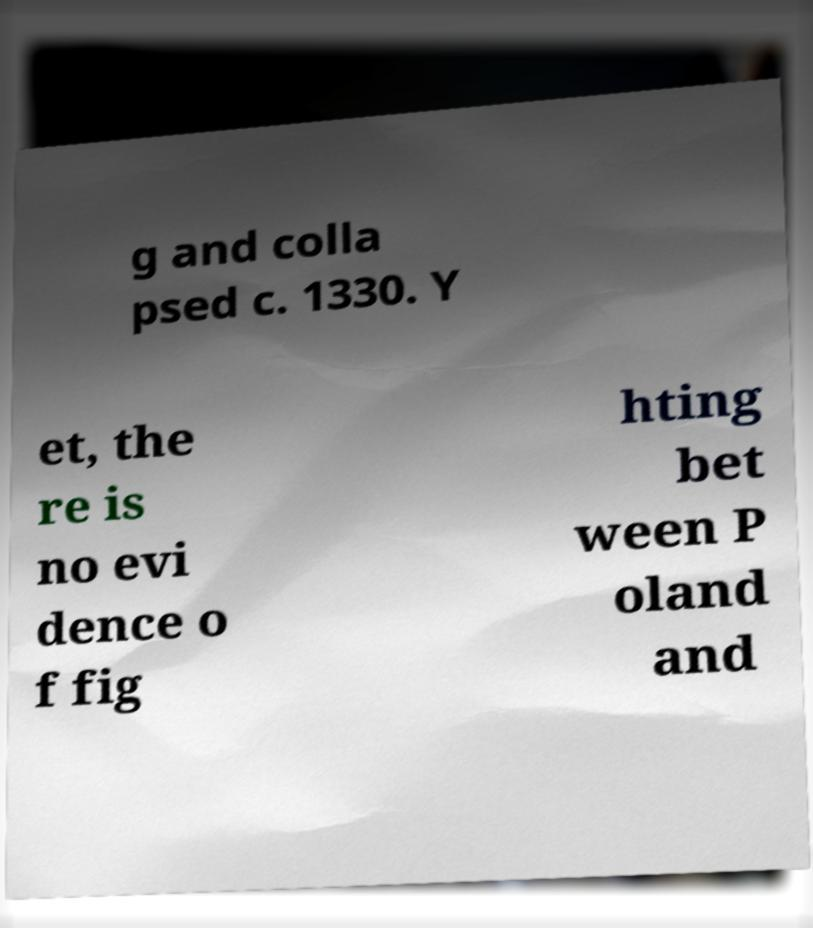Can you accurately transcribe the text from the provided image for me? g and colla psed c. 1330. Y et, the re is no evi dence o f fig hting bet ween P oland and 